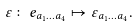<formula> <loc_0><loc_0><loc_500><loc_500>\varepsilon \colon e _ { a _ { 1 } \dots a _ { 4 } } \mapsto \varepsilon _ { a _ { 1 } \dots a _ { 4 } } .</formula> 